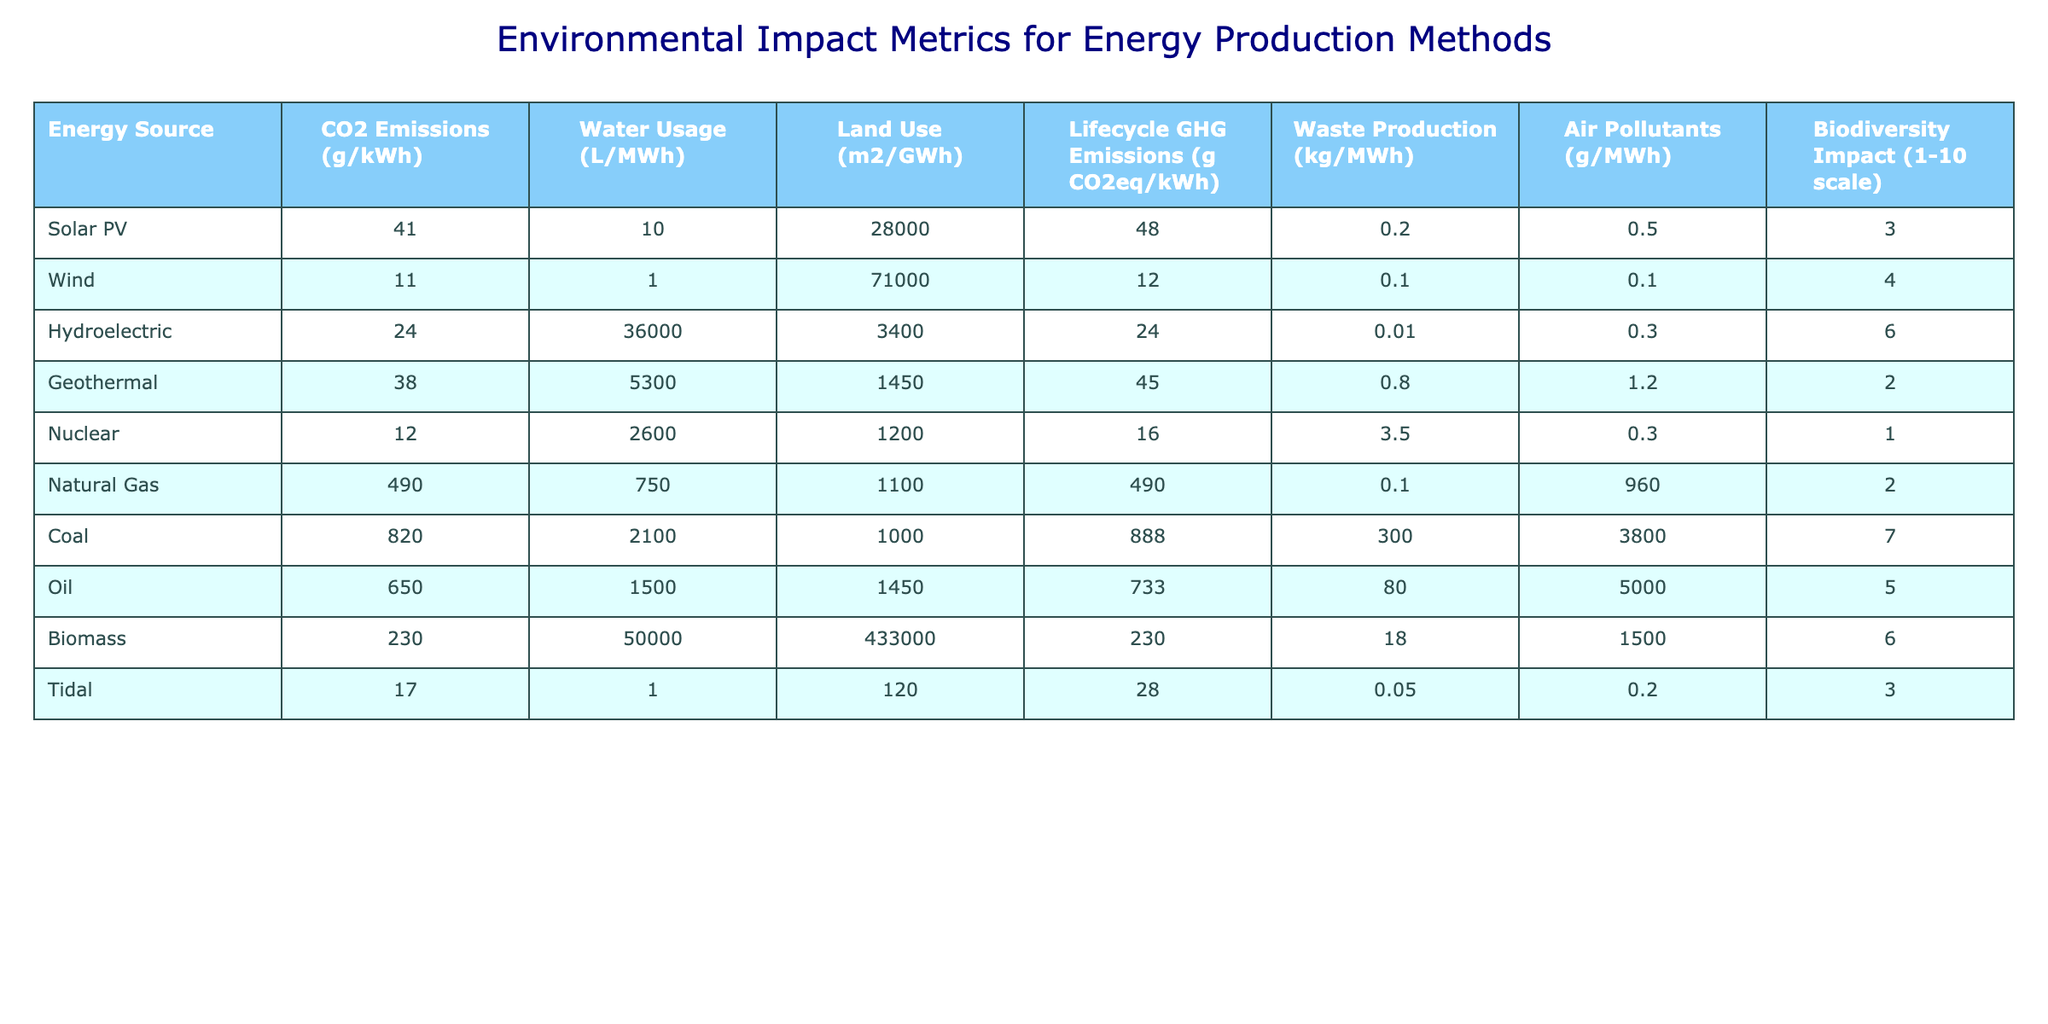What is the CO2 emissions for Wind energy? The table shows that the CO2 emissions for Wind energy are listed as 11 g/kWh.
Answer: 11 g/kWh Which energy source has the highest lifecycle GHG emissions? By comparing the values in the table, Coal has the highest lifecycle GHG emissions at 888 g CO2eq/kWh.
Answer: Coal What is the average water usage for renewable energy sources (Solar PV, Wind, Hydroelectric, Geothermal, and Biomass)? The water usage values for the renewable sources are: Solar PV (10), Wind (1), Hydroelectric (36000), Geothermal (5300), and Biomass (50000). Summing them gives 10 + 1 + 36000 + 5300 + 50000 = 91311. Dividing by 5 (number of sources) gives an average of 18262.2 L/MWh.
Answer: 18262.2 L/MWh Is the biodiversity impact of Natural Gas higher than that of Geothermal energy? The biodiversity impact for Natural Gas is 2 and for Geothermal is 2 as well, so they are equal. Therefore, the statement is false.
Answer: No Which energy source has the lowest waste production? The table indicates that Wind energy has the lowest waste production listed as 0.1 kg/MWh, lower than all other sources.
Answer: Wind What is the difference in CO2 emissions between Coal and Natural Gas? The CO2 emissions for Coal are 820 g/kWh, and for Natural Gas, it is 490 g/kWh. The difference is calculated as 820 - 490 = 330 g/kWh.
Answer: 330 g/kWh Which energy source has the highest air pollutants production? Referring to the table, Coal emits the most air pollutants with 3800 g/MWh, surpassing all other sources.
Answer: Coal If we consider only renewable sources, what is the total land use in m² for Wind, Solar PV, and Hydroelectric? The land use values for the renewable sources are: Solar PV (28000 m2/GWh), Wind (71000 m2/GWh), and Hydroelectric (3400 m2/GWh). Adding these, we have 28000 + 71000 + 3400 = 102400 m²/GWh.
Answer: 102400 m²/GWh Does Biomass produce more CO2 emissions than Nuclear energy? The CO2 emissions for Biomass are 230 g/kWh, while for Nuclear energy, it is 12 g/kWh. Since 230 is greater than 12, the statement is true.
Answer: Yes What is the average biodiversity impact for all energy sources? The biodiversity impacts are: Solar PV (3), Wind (4), Hydroelectric (6), Geothermal (2), Nuclear (1), Natural Gas (2), Coal (7), Oil (5), and Biomass (6). Adding these gives 3 + 4 + 6 + 2 + 1 + 2 + 7 + 5 + 6 = 36. Dividing by 9 (number of sources) gives an average of 4.
Answer: 4 